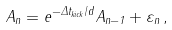<formula> <loc_0><loc_0><loc_500><loc_500>A _ { n } = e ^ { - \Delta t _ { k i c k } / d } A _ { n - 1 } + \varepsilon _ { n } \, ,</formula> 